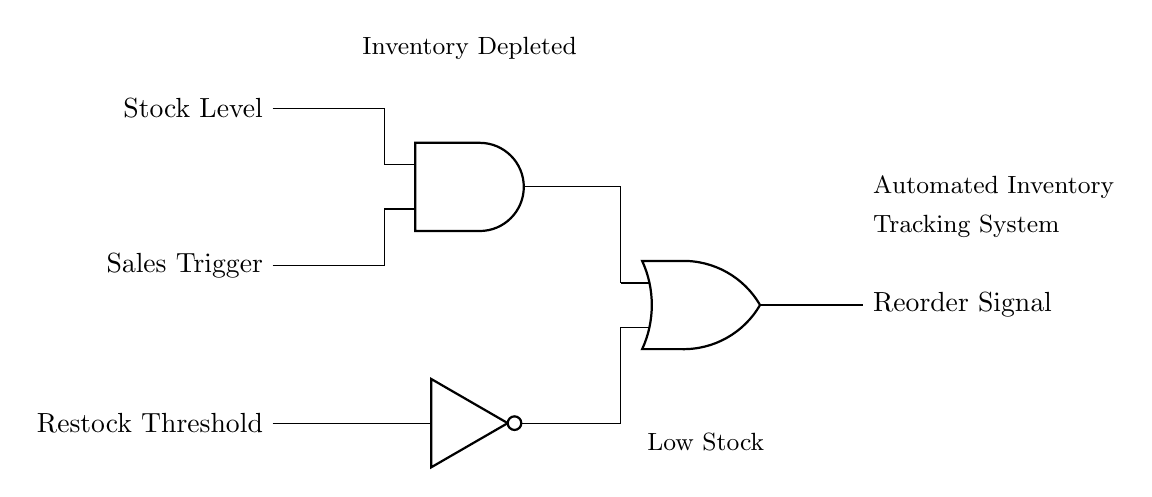What are the input signals used in this circuit? The input signals are Stock Level, Sales Trigger, and Restock Threshold, which represent the conditions that influence the inventory system's decisions.
Answer: Stock Level, Sales Trigger, Restock Threshold What type of logic gate is used to combine Stock Level and Sales Trigger? The circuit uses an AND gate, which requires both input signals (Stock Level and Sales Trigger) to be true for its output to be activated.
Answer: AND gate What does the NOT gate in the circuit do? The NOT gate inverts the input it receives from the Restock Threshold, changing a true signal to false or vice versa, which affects the final output.
Answer: Invert signal What is the purpose of the OR gate in this circuit? The OR gate combines the outputs from the AND gate and the NOT gate, allowing the Reorder Signal to be generated if either condition met: sufficient stock and sales trigger or low stock warning.
Answer: Combine signals How many logic gates are present in this circuit? There are three logic gates present: one AND gate, one NOT gate, and one OR gate. This helps in decision-making for inventory management.
Answer: Three What does the output signal represent? The output signal represents the Reorder Signal, indicating when the system should reorder inventory based on set conditions.
Answer: Reorder Signal 